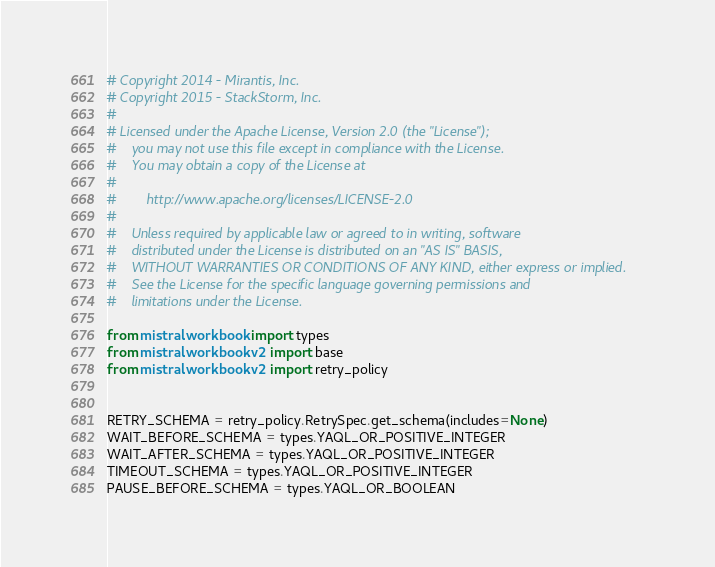<code> <loc_0><loc_0><loc_500><loc_500><_Python_># Copyright 2014 - Mirantis, Inc.
# Copyright 2015 - StackStorm, Inc.
#
# Licensed under the Apache License, Version 2.0 (the "License");
#    you may not use this file except in compliance with the License.
#    You may obtain a copy of the License at
#
#        http://www.apache.org/licenses/LICENSE-2.0
#
#    Unless required by applicable law or agreed to in writing, software
#    distributed under the License is distributed on an "AS IS" BASIS,
#    WITHOUT WARRANTIES OR CONDITIONS OF ANY KIND, either express or implied.
#    See the License for the specific language governing permissions and
#    limitations under the License.

from mistral.workbook import types
from mistral.workbook.v2 import base
from mistral.workbook.v2 import retry_policy


RETRY_SCHEMA = retry_policy.RetrySpec.get_schema(includes=None)
WAIT_BEFORE_SCHEMA = types.YAQL_OR_POSITIVE_INTEGER
WAIT_AFTER_SCHEMA = types.YAQL_OR_POSITIVE_INTEGER
TIMEOUT_SCHEMA = types.YAQL_OR_POSITIVE_INTEGER
PAUSE_BEFORE_SCHEMA = types.YAQL_OR_BOOLEAN</code> 